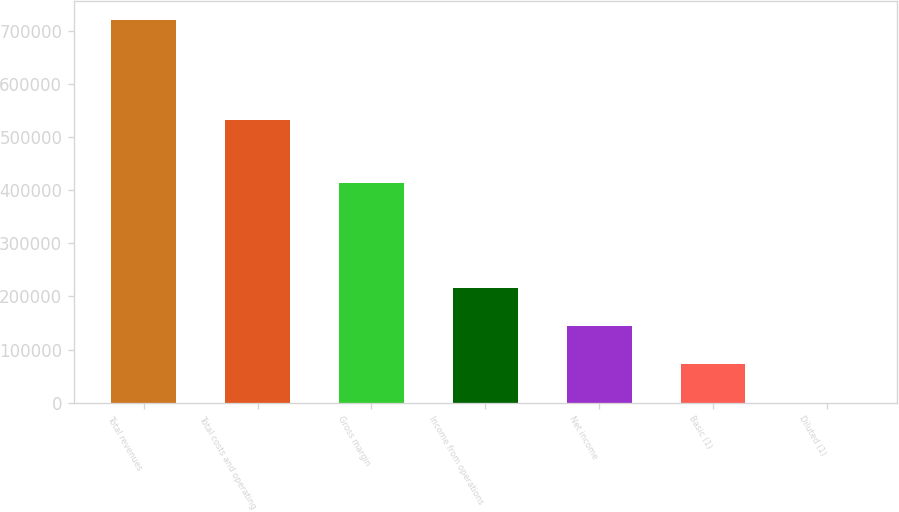<chart> <loc_0><loc_0><loc_500><loc_500><bar_chart><fcel>Total revenues<fcel>Total costs and operating<fcel>Gross margin<fcel>Income from operations<fcel>Net income<fcel>Basic (1)<fcel>Diluted (1)<nl><fcel>720032<fcel>532397<fcel>413228<fcel>216010<fcel>144007<fcel>72003.9<fcel>0.8<nl></chart> 